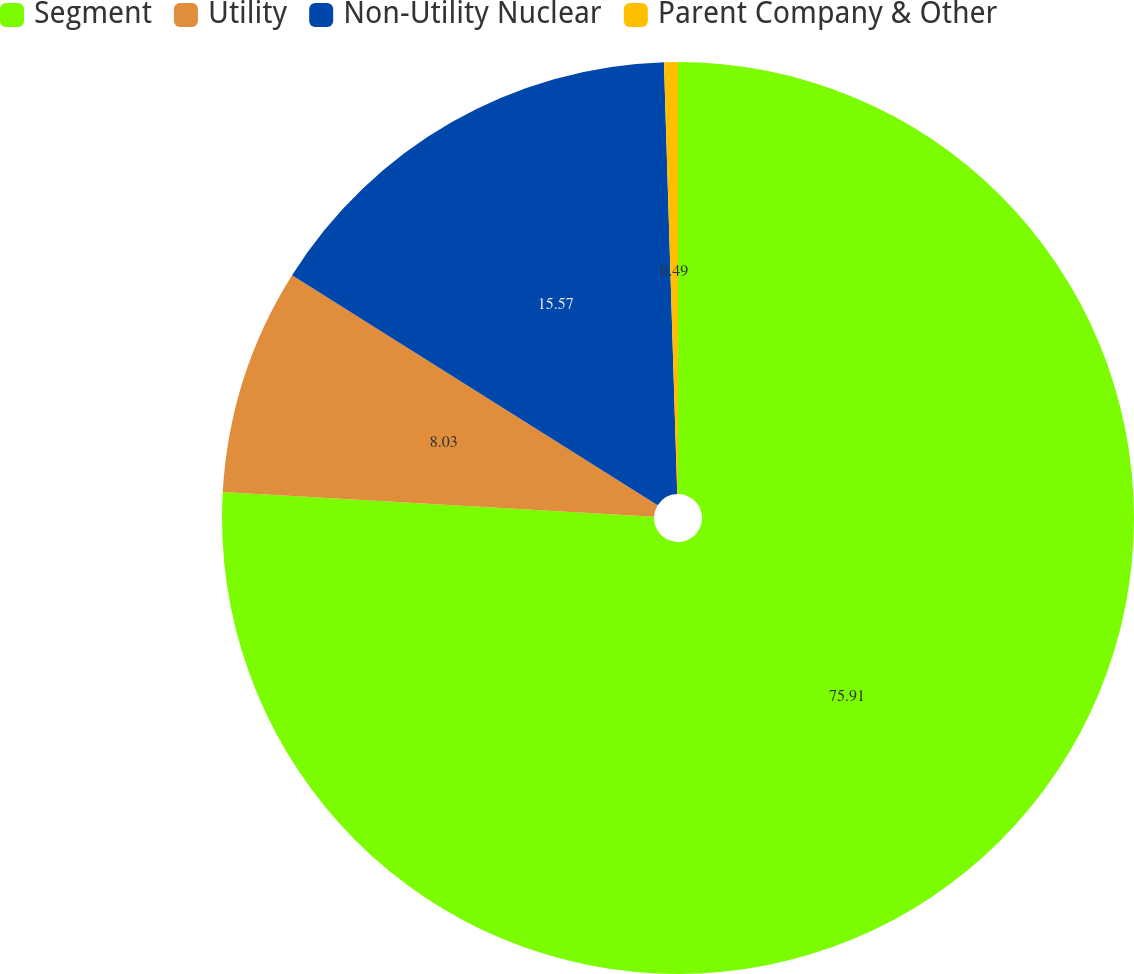Convert chart. <chart><loc_0><loc_0><loc_500><loc_500><pie_chart><fcel>Segment<fcel>Utility<fcel>Non-Utility Nuclear<fcel>Parent Company & Other<nl><fcel>75.9%<fcel>8.03%<fcel>15.57%<fcel>0.49%<nl></chart> 